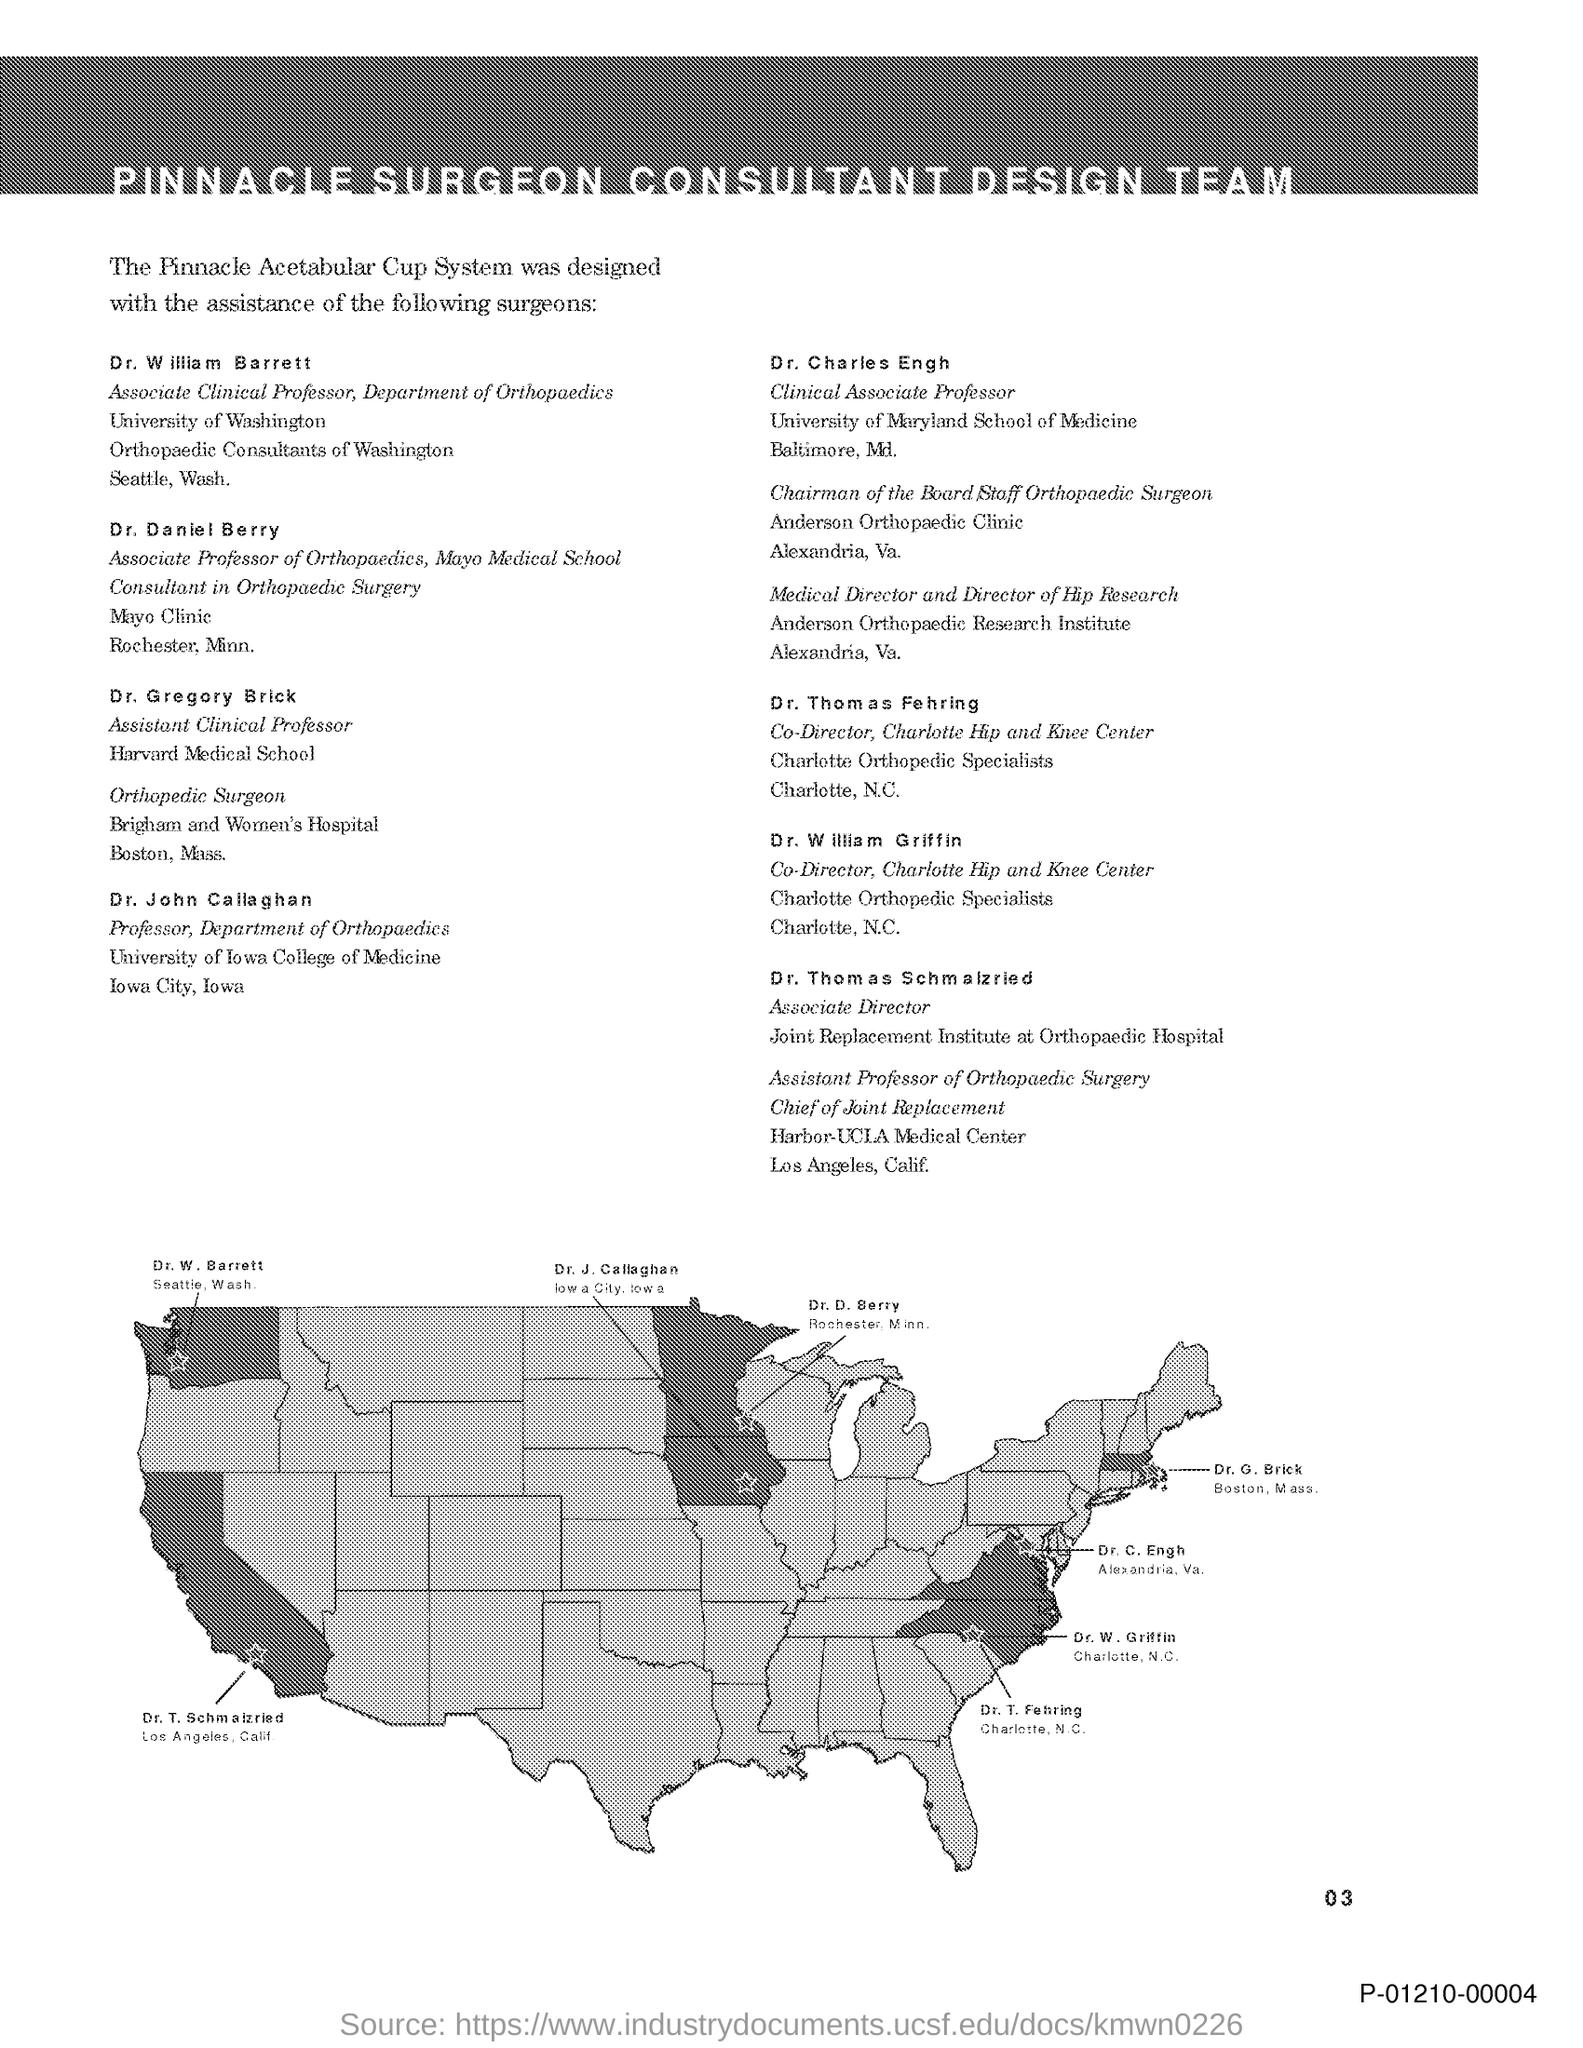What is the title of this document?
Make the answer very short. PINNACLE SURGEON CONSULTANT DESIGN TEAM. What is the designation of Dr. William Barnett?
Offer a very short reply. ASSOCIATE CLINICAL PROFESSOR, DEPARTMENT OF ORTHOPAEDICS. What is the designation of Dr. John Callaghan?
Your answer should be compact. PROFESSOR, DEPARTMENT OF ORTHOPAEDICS. 